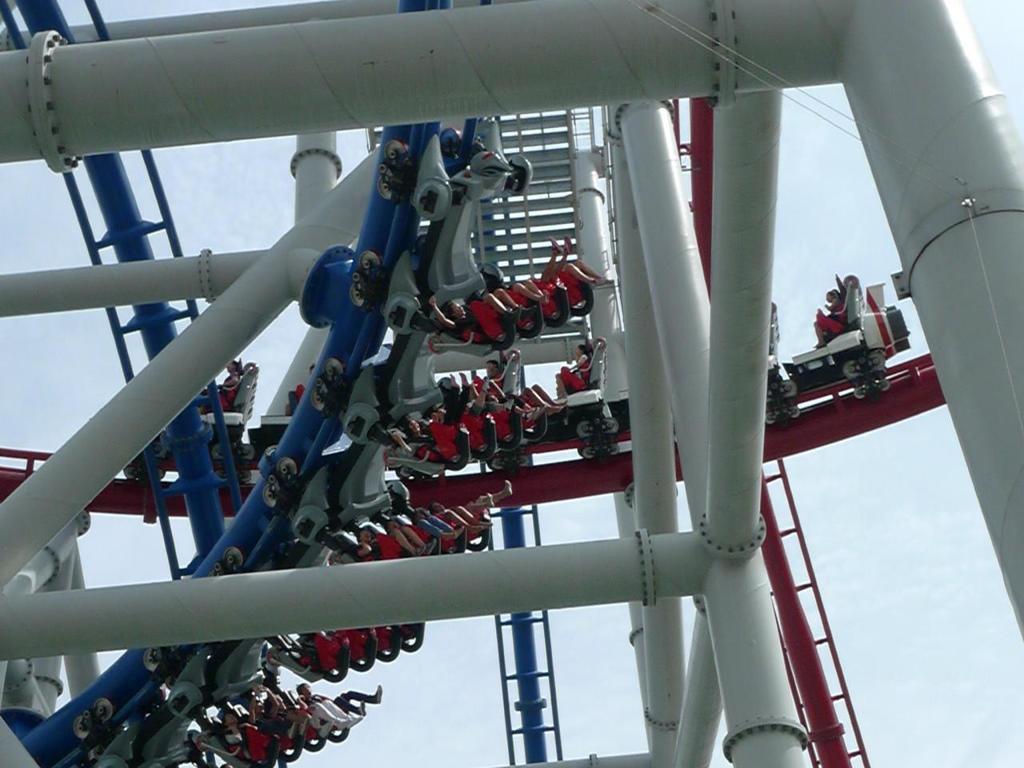Describe this image in one or two sentences. In this picture we can see some people are riding the roller coaster. Behind the people there are poles and the sky. 